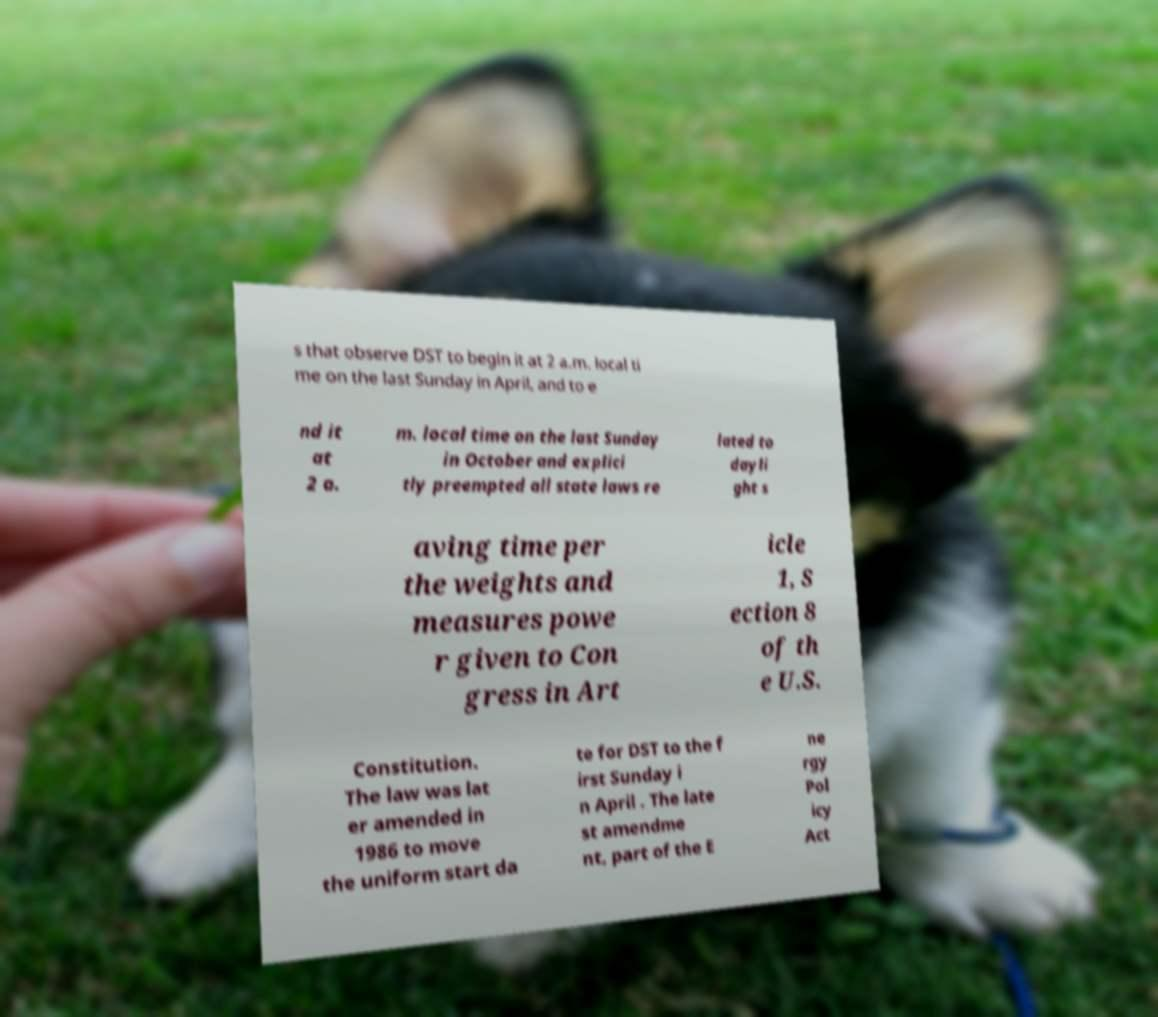Please identify and transcribe the text found in this image. s that observe DST to begin it at 2 a.m. local ti me on the last Sunday in April, and to e nd it at 2 a. m. local time on the last Sunday in October and explici tly preempted all state laws re lated to dayli ght s aving time per the weights and measures powe r given to Con gress in Art icle 1, S ection 8 of th e U.S. Constitution. The law was lat er amended in 1986 to move the uniform start da te for DST to the f irst Sunday i n April . The late st amendme nt, part of the E ne rgy Pol icy Act 